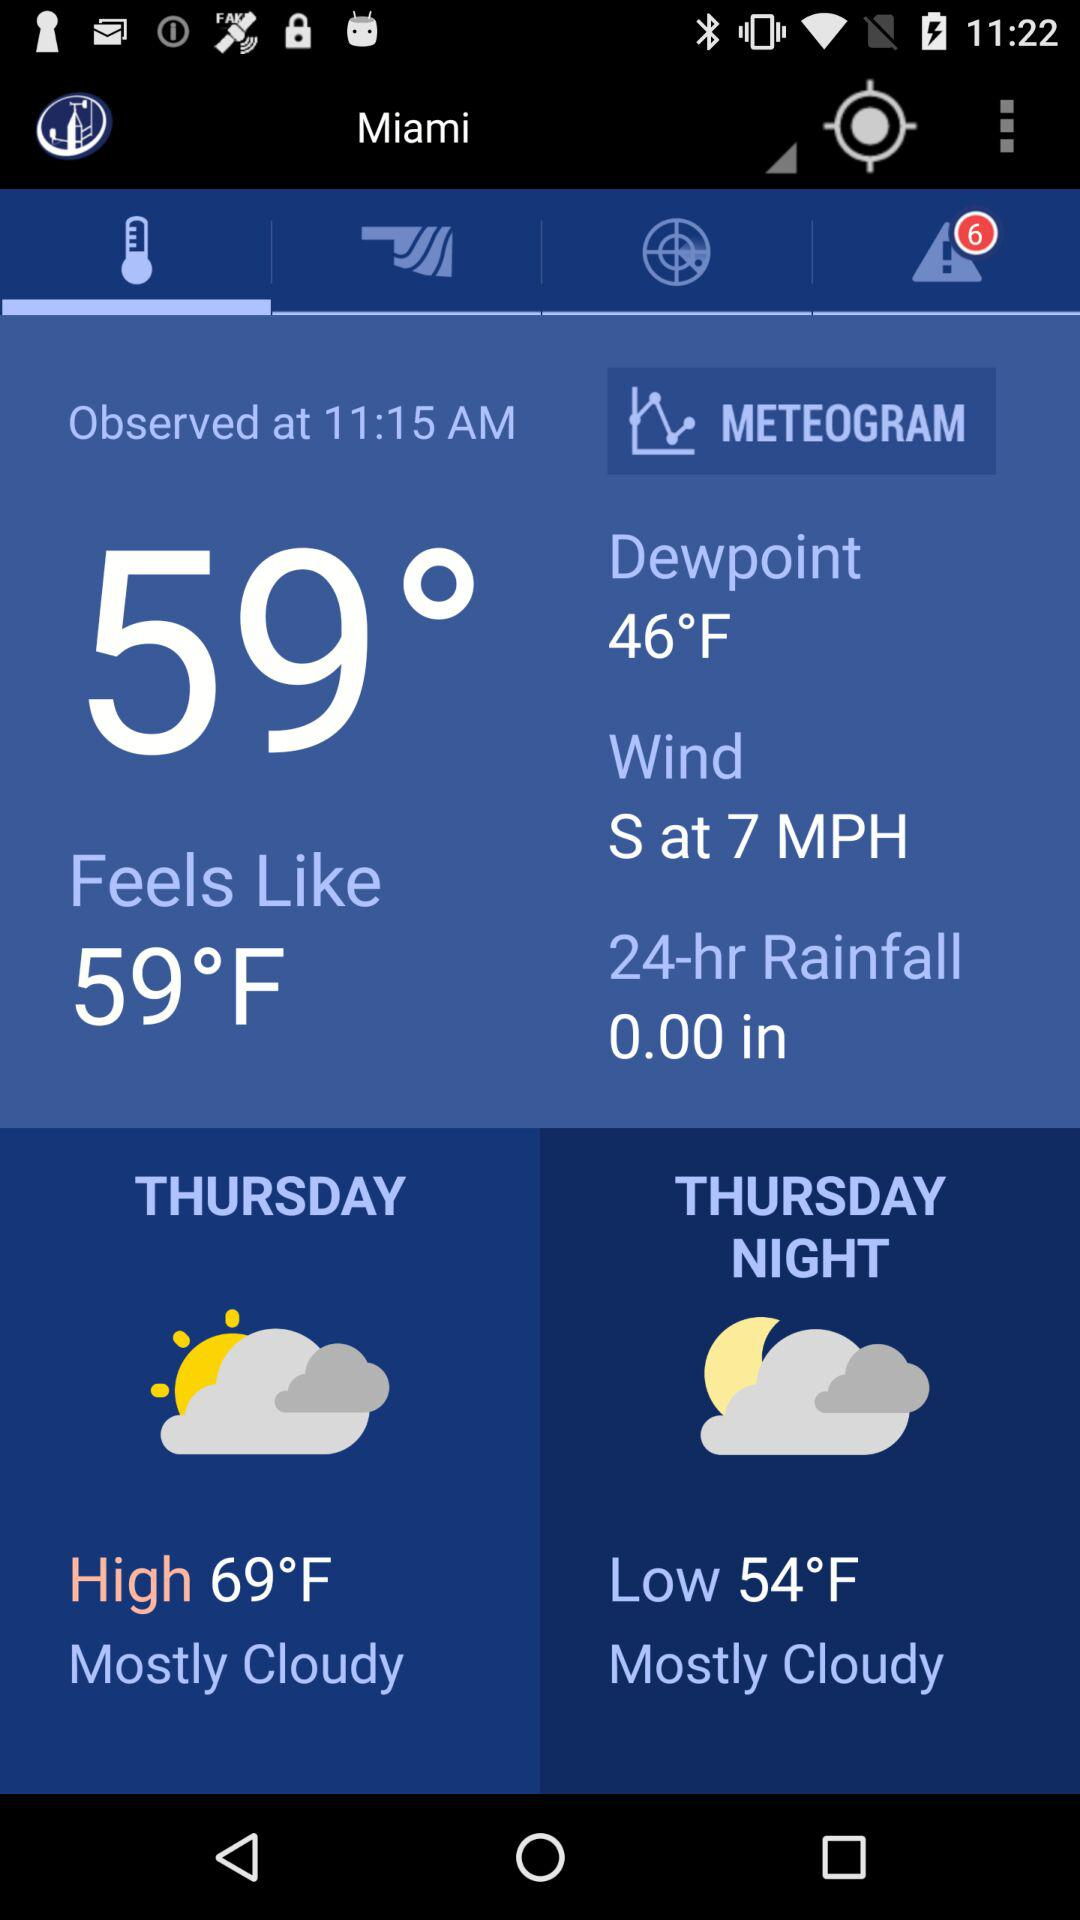What is the weather forecast for Thursday night?
Answer the question using a single word or phrase. The weather forecast is "Mostly Cloudy" 